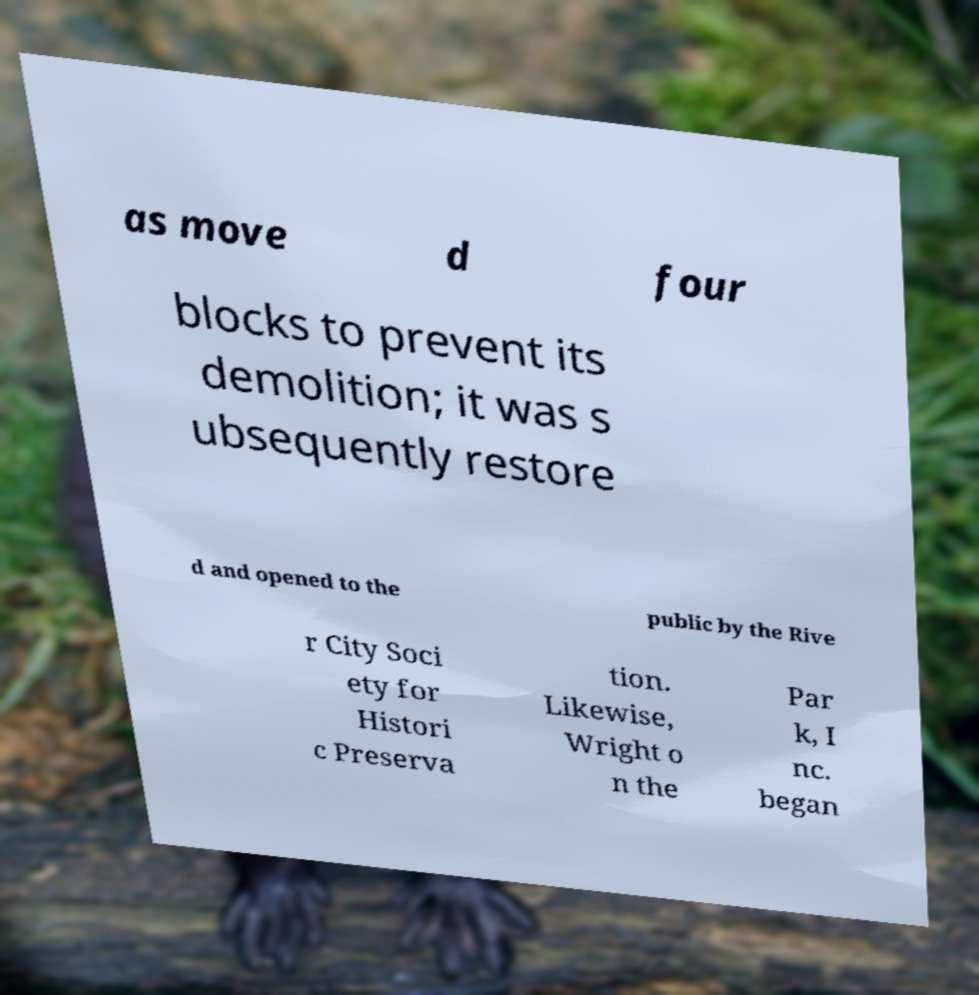What messages or text are displayed in this image? I need them in a readable, typed format. as move d four blocks to prevent its demolition; it was s ubsequently restore d and opened to the public by the Rive r City Soci ety for Histori c Preserva tion. Likewise, Wright o n the Par k, I nc. began 